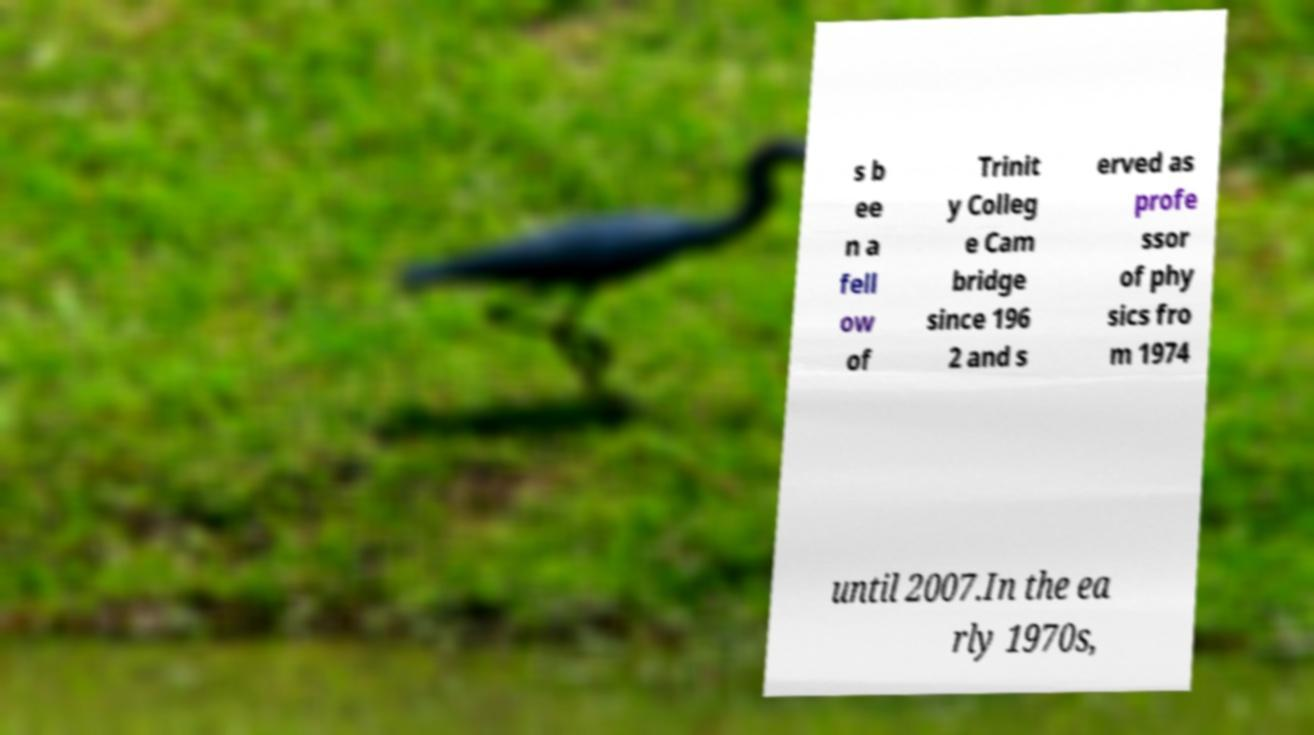There's text embedded in this image that I need extracted. Can you transcribe it verbatim? s b ee n a fell ow of Trinit y Colleg e Cam bridge since 196 2 and s erved as profe ssor of phy sics fro m 1974 until 2007.In the ea rly 1970s, 